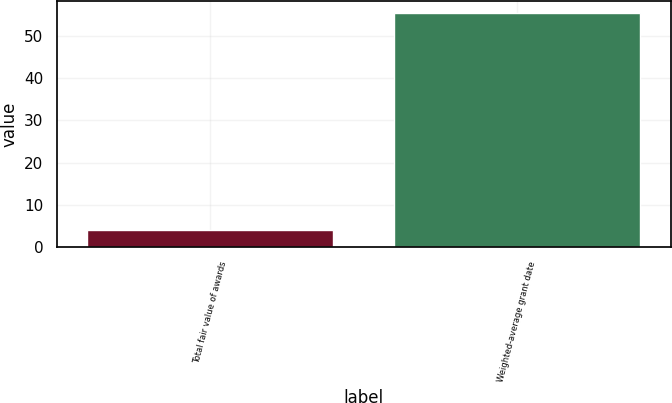<chart> <loc_0><loc_0><loc_500><loc_500><bar_chart><fcel>Total fair value of awards<fcel>Weighted-average grant date<nl><fcel>4.2<fcel>55.43<nl></chart> 